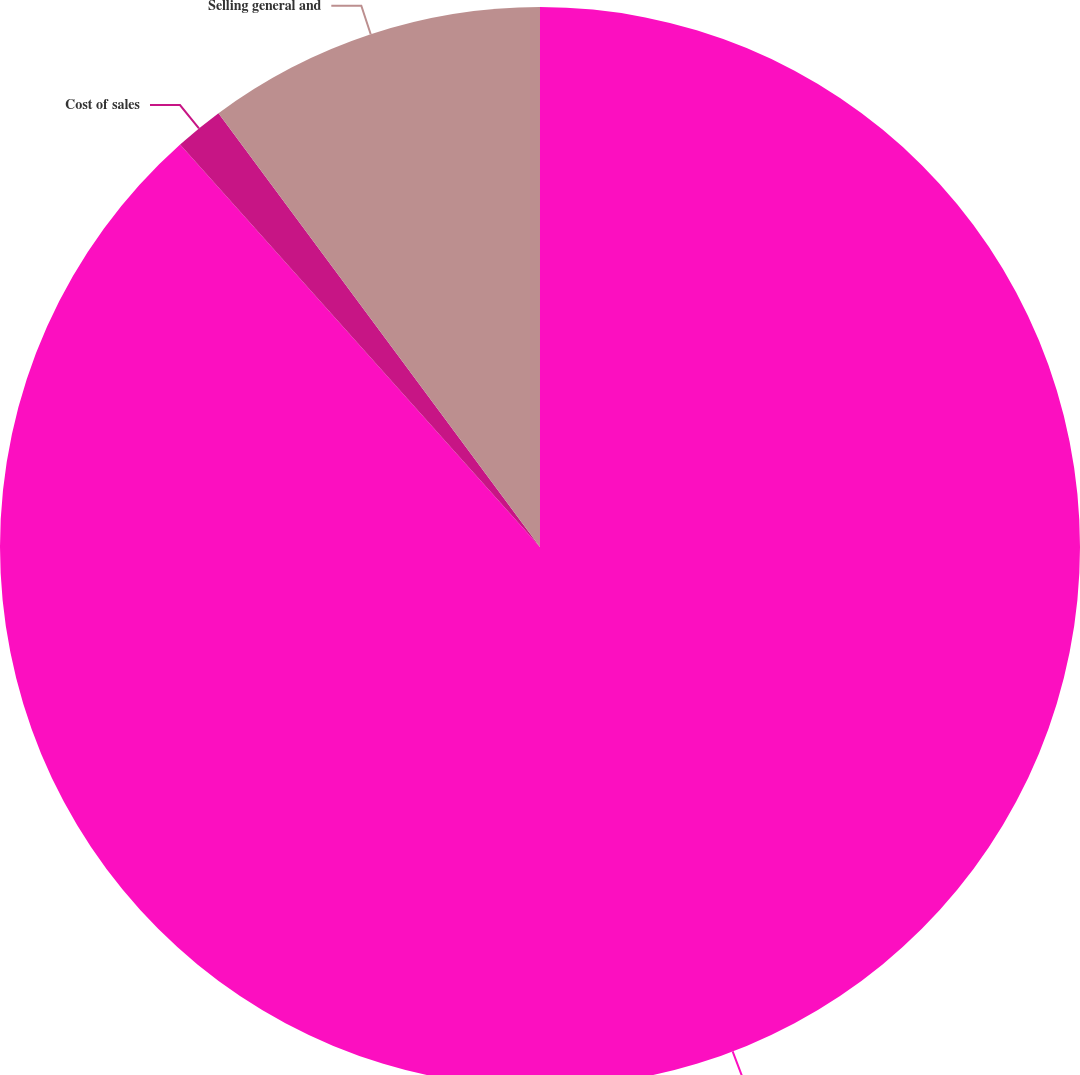Convert chart. <chart><loc_0><loc_0><loc_500><loc_500><pie_chart><fcel>Statement of Earnings Caption<fcel>Cost of sales<fcel>Selling general and<nl><fcel>88.39%<fcel>1.46%<fcel>10.15%<nl></chart> 